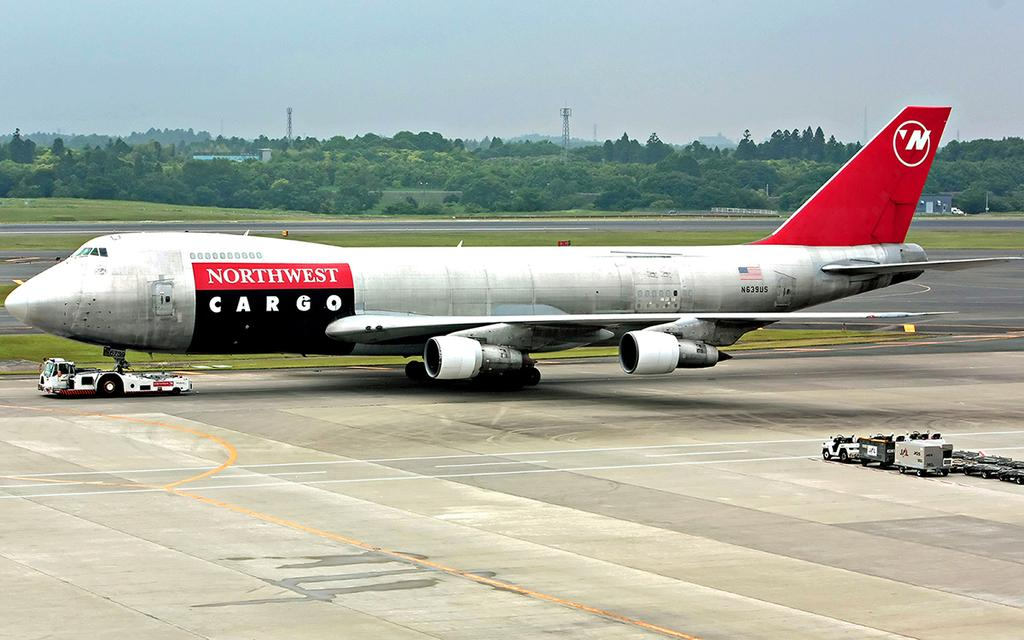<image>
Write a terse but informative summary of the picture. Northwest cargo airplane on the concrete at the airport. 